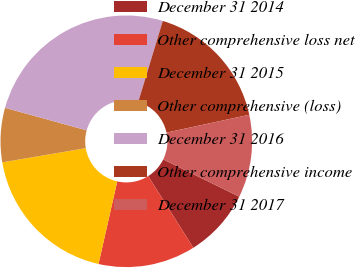Convert chart. <chart><loc_0><loc_0><loc_500><loc_500><pie_chart><fcel>December 31 2014<fcel>Other comprehensive loss net<fcel>December 31 2015<fcel>Other comprehensive (loss)<fcel>December 31 2016<fcel>Other comprehensive income<fcel>December 31 2017<nl><fcel>8.8%<fcel>12.49%<fcel>18.78%<fcel>6.96%<fcel>25.4%<fcel>16.93%<fcel>10.64%<nl></chart> 